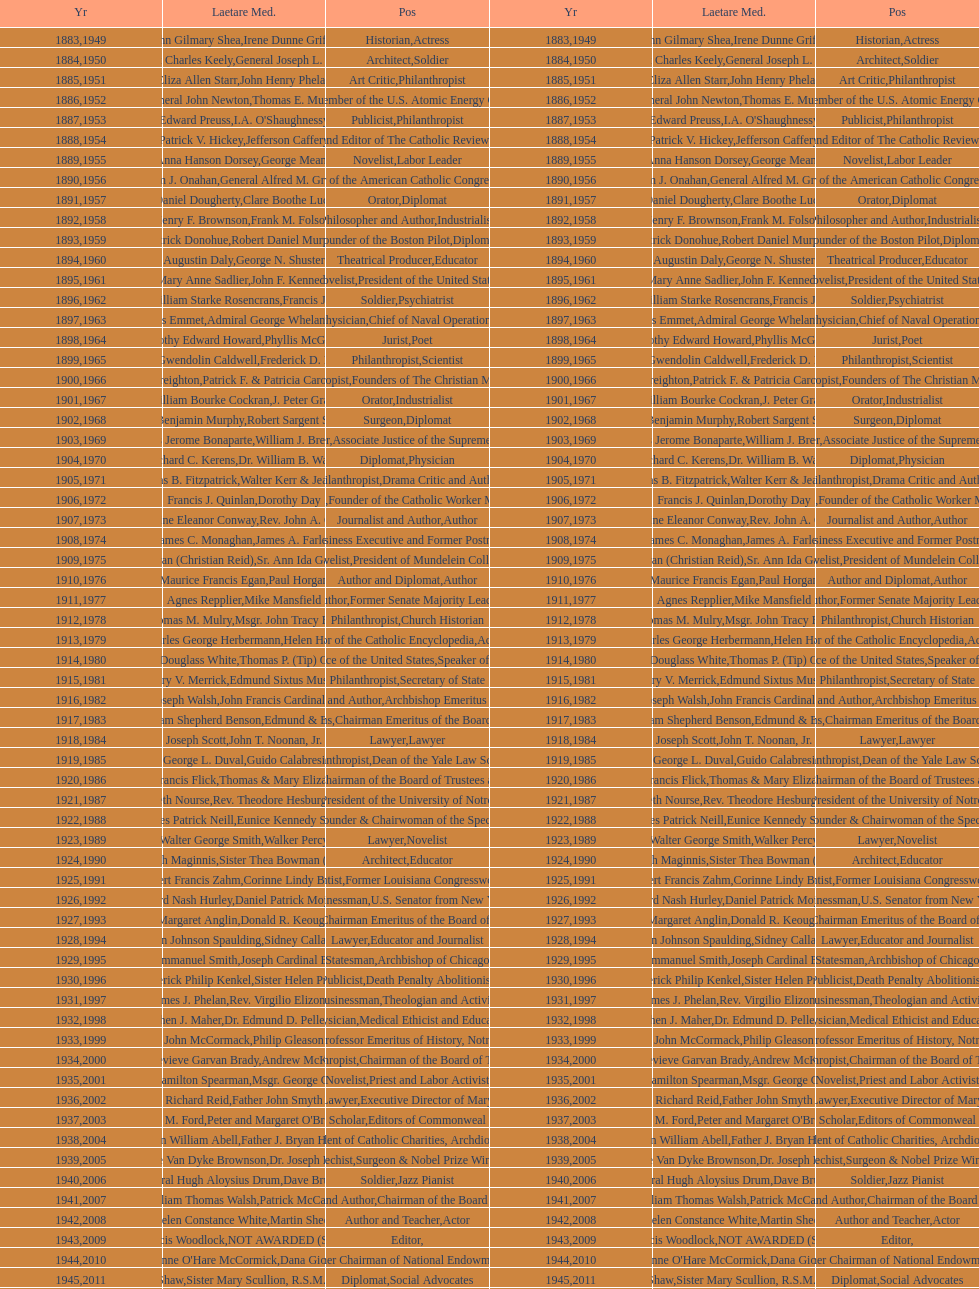How many laetare medalists were philantrohpists? 2. 